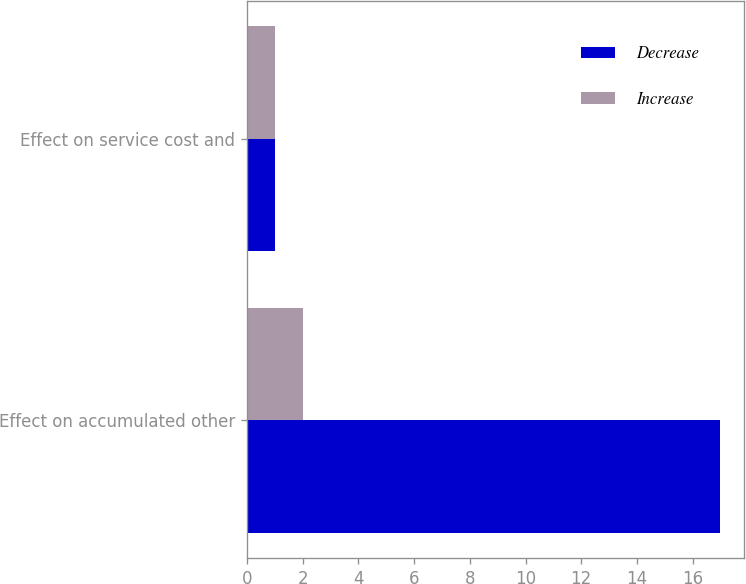Convert chart. <chart><loc_0><loc_0><loc_500><loc_500><stacked_bar_chart><ecel><fcel>Effect on accumulated other<fcel>Effect on service cost and<nl><fcel>Decrease<fcel>17<fcel>1<nl><fcel>Increase<fcel>2<fcel>1<nl></chart> 